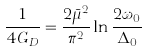Convert formula to latex. <formula><loc_0><loc_0><loc_500><loc_500>\frac { 1 } { 4 G _ { D } } = \frac { 2 \bar { \mu } ^ { 2 } } { \pi ^ { 2 } } \ln \frac { 2 \omega _ { 0 } } { \Delta _ { 0 } }</formula> 